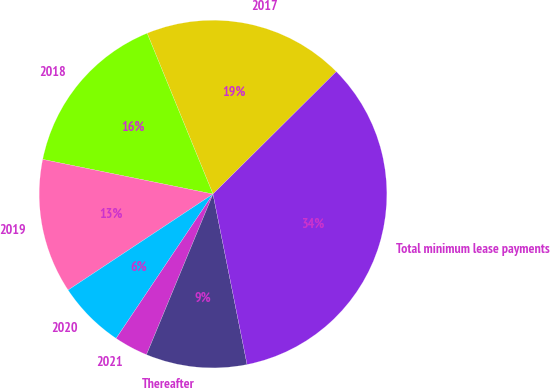Convert chart to OTSL. <chart><loc_0><loc_0><loc_500><loc_500><pie_chart><fcel>2017<fcel>2018<fcel>2019<fcel>2020<fcel>2021<fcel>Thereafter<fcel>Total minimum lease payments<nl><fcel>18.74%<fcel>15.62%<fcel>12.51%<fcel>6.28%<fcel>3.16%<fcel>9.39%<fcel>34.31%<nl></chart> 